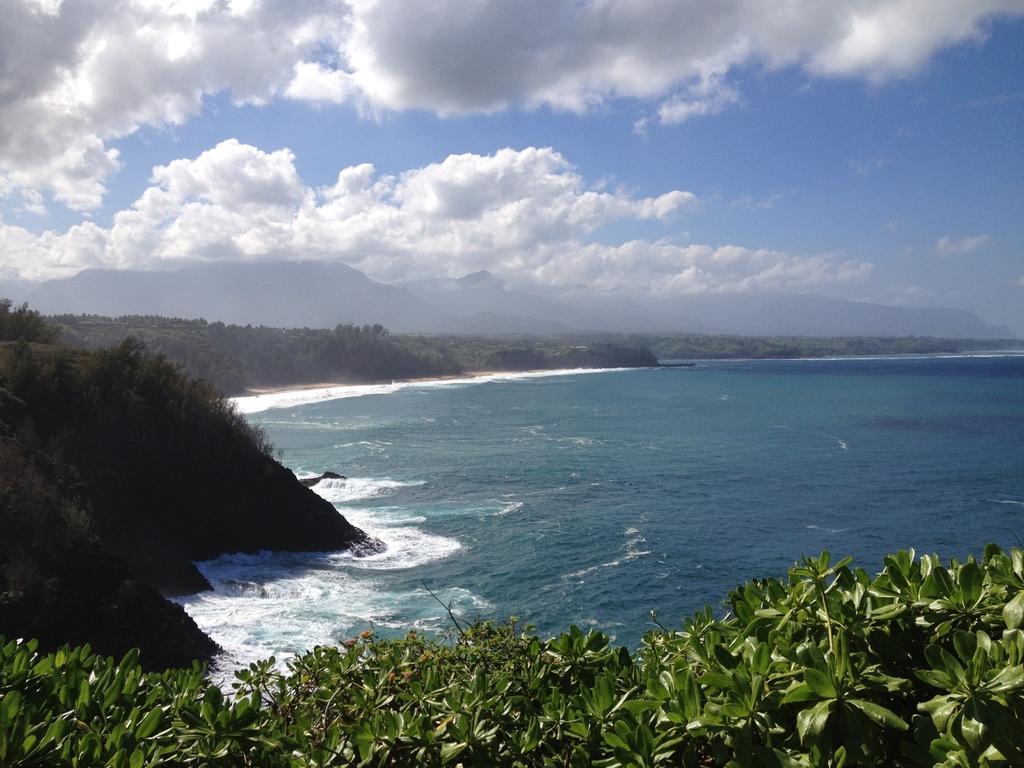In one or two sentences, can you explain what this image depicts? In this image I can see number of green colour leaves, water clouds and the sky. 